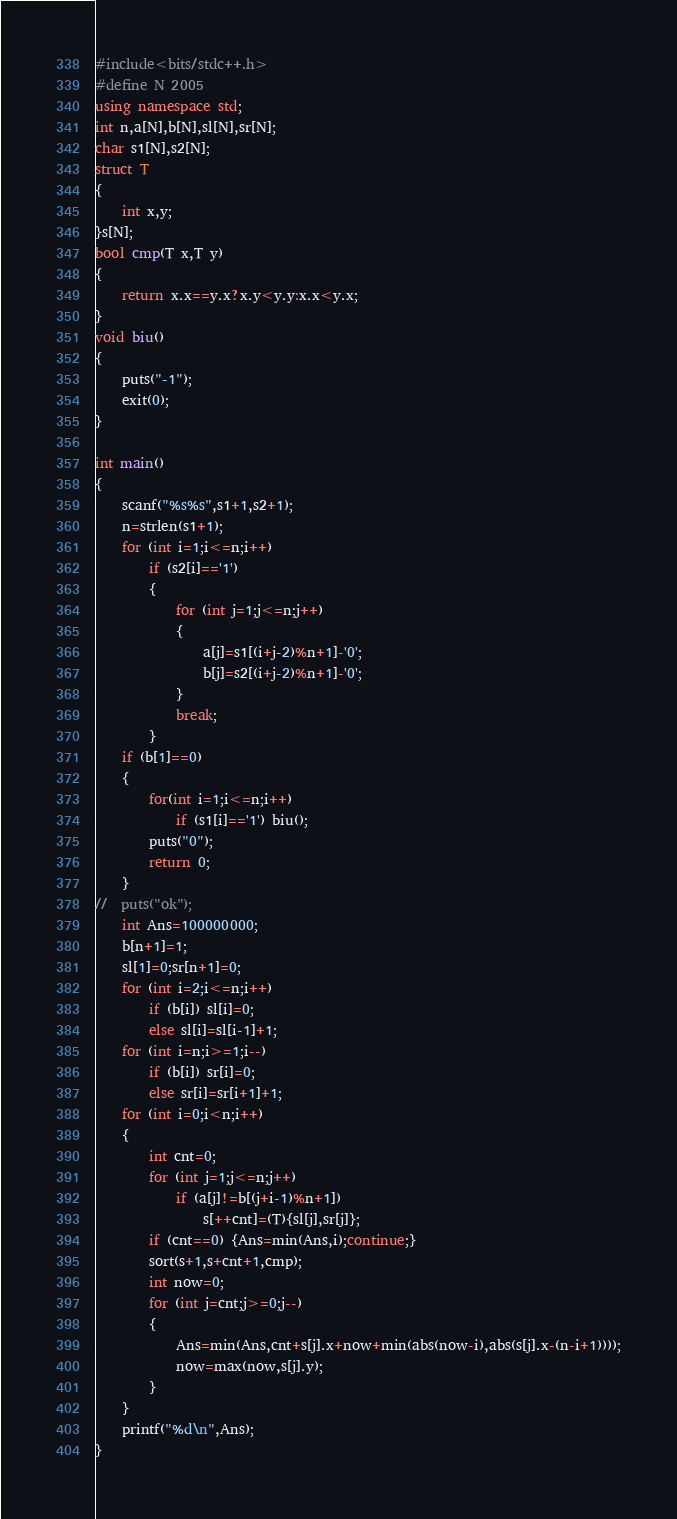<code> <loc_0><loc_0><loc_500><loc_500><_C++_>#include<bits/stdc++.h>
#define N 2005
using namespace std;
int n,a[N],b[N],sl[N],sr[N];
char s1[N],s2[N];
struct T
{
	int x,y;
}s[N];
bool cmp(T x,T y)
{
	return x.x==y.x?x.y<y.y:x.x<y.x;
}
void biu()
{
	puts("-1");
	exit(0);
}

int main()
{
	scanf("%s%s",s1+1,s2+1);
	n=strlen(s1+1);
	for (int i=1;i<=n;i++)
		if (s2[i]=='1')
		{
			for (int j=1;j<=n;j++)
			{
				a[j]=s1[(i+j-2)%n+1]-'0';
				b[j]=s2[(i+j-2)%n+1]-'0';
			}
			break;
		}
	if (b[1]==0)
	{
		for(int i=1;i<=n;i++)
			if (s1[i]=='1') biu();
		puts("0");
		return 0;
	}
//	puts("ok");
	int Ans=100000000;
	b[n+1]=1;
	sl[1]=0;sr[n+1]=0;
	for (int i=2;i<=n;i++)
		if (b[i]) sl[i]=0;
		else sl[i]=sl[i-1]+1;
	for (int i=n;i>=1;i--)
		if (b[i]) sr[i]=0;
		else sr[i]=sr[i+1]+1;
	for (int i=0;i<n;i++)
	{
		int cnt=0;
		for (int j=1;j<=n;j++)
			if (a[j]!=b[(j+i-1)%n+1])
				s[++cnt]=(T){sl[j],sr[j]};
		if (cnt==0) {Ans=min(Ans,i);continue;}
		sort(s+1,s+cnt+1,cmp);
		int now=0;
		for (int j=cnt;j>=0;j--)
		{
			Ans=min(Ans,cnt+s[j].x+now+min(abs(now-i),abs(s[j].x-(n-i+1))));
			now=max(now,s[j].y);
		}
	}
	printf("%d\n",Ans);
}</code> 